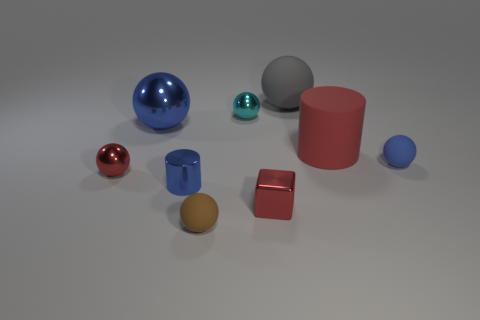There is a cylinder that is on the right side of the small blue cylinder; what size is it?
Provide a succinct answer. Large. Is there anything else that has the same color as the tiny cylinder?
Ensure brevity in your answer.  Yes. Are there any small cyan metal balls that are in front of the blue shiny object that is in front of the small matte sphere that is behind the red metallic block?
Your response must be concise. No. There is a tiny rubber object behind the small red shiny sphere; does it have the same color as the small metal cylinder?
Your answer should be very brief. Yes. What number of spheres are big objects or matte things?
Ensure brevity in your answer.  4. What is the shape of the blue object that is to the right of the large sphere that is to the right of the red shiny cube?
Your answer should be very brief. Sphere. There is a blue metallic ball that is on the left side of the red object that is behind the small rubber thing behind the tiny brown matte ball; what is its size?
Your answer should be compact. Large. Does the brown rubber sphere have the same size as the gray thing?
Offer a terse response. No. How many things are either red blocks or small cylinders?
Your answer should be compact. 2. There is a cylinder that is in front of the blue ball that is to the right of the tiny brown ball; how big is it?
Your response must be concise. Small. 